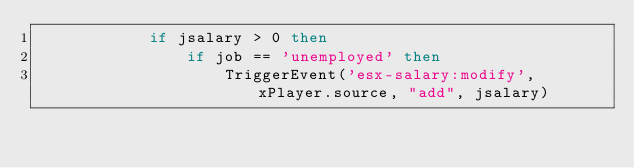Convert code to text. <code><loc_0><loc_0><loc_500><loc_500><_Lua_>			if jsalary > 0 then
				if job == 'unemployed' then
					TriggerEvent('esx-salary:modify', xPlayer.source, "add", jsalary)</code> 